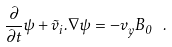Convert formula to latex. <formula><loc_0><loc_0><loc_500><loc_500>\frac { \partial } { \partial t } \psi + \vec { v } _ { i } . \nabla \psi = - v _ { y } B _ { 0 } \ .</formula> 